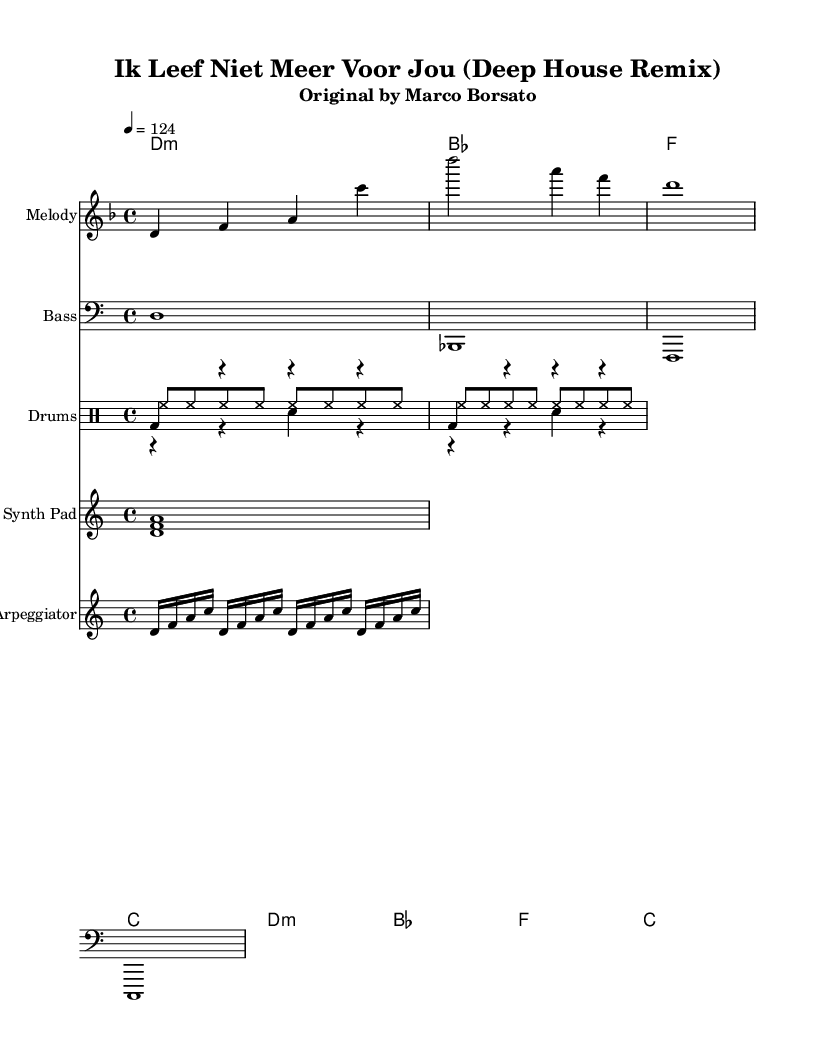What is the key signature of this music? The key signature indicated at the beginning of the score is D minor, which has one flat (B flat).
Answer: D minor What is the time signature of this music? The time signature is presented as 4/4 at the beginning of the piece, meaning there are four beats in each measure.
Answer: 4/4 What is the tempo marking for this piece? The tempo marking states "4 = 124," which indicates that there are 124 beats per minute.
Answer: 124 How many measures are in the melody section? The melody section presents a total of three measures, counting each line individually.
Answer: 3 What type of chord is indicated at the start of the harmony? The first chord in the harmony section is D minor, indicated by the "d1:m" notation.
Answer: D minor What instrument is the synth pad part written for? The synth pad part is written for "Synth Pad," as labeled above that staff in the sheet music.
Answer: Synth Pad How many different drum voices are present in the score? There are three separate drum voices represented in the score: kick, snare, and hi-hat.
Answer: 3 